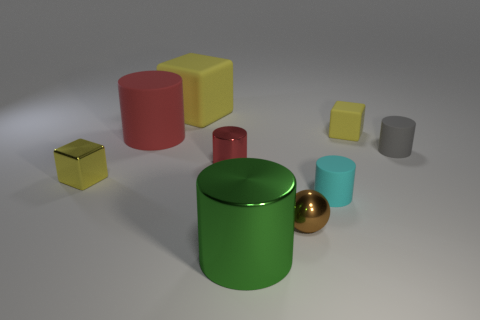Is there any other thing that has the same shape as the small brown metallic thing?
Offer a very short reply. No. Is the color of the rubber cylinder to the left of the large rubber cube the same as the small metal cylinder?
Make the answer very short. Yes. How many yellow objects are right of the green object?
Offer a very short reply. 1. Are the brown sphere and the big cylinder that is in front of the cyan cylinder made of the same material?
Provide a succinct answer. Yes. There is a yellow cube that is made of the same material as the large yellow object; what is its size?
Make the answer very short. Small. Is the number of cubes left of the green object greater than the number of red objects that are behind the small gray matte cylinder?
Keep it short and to the point. Yes. Are there any small brown objects of the same shape as the tiny gray object?
Give a very brief answer. No. Is the size of the gray matte thing in front of the red matte object the same as the large yellow rubber object?
Your response must be concise. No. Are there any gray cubes?
Provide a succinct answer. No. What number of objects are either spheres that are right of the tiny metal cube or small cylinders?
Offer a very short reply. 4. 